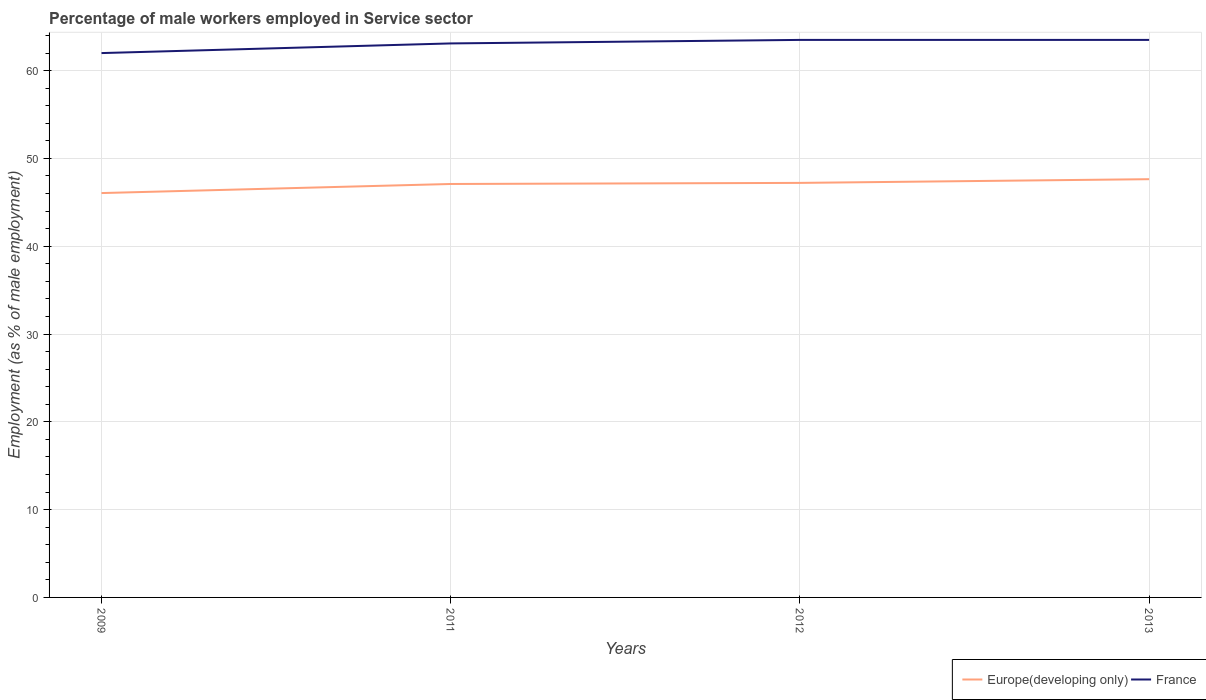Across all years, what is the maximum percentage of male workers employed in Service sector in France?
Provide a succinct answer. 62. What is the total percentage of male workers employed in Service sector in Europe(developing only) in the graph?
Provide a succinct answer. -1.03. What is the difference between the highest and the second highest percentage of male workers employed in Service sector in France?
Provide a succinct answer. 1.5. What is the difference between the highest and the lowest percentage of male workers employed in Service sector in Europe(developing only)?
Ensure brevity in your answer.  3. How many years are there in the graph?
Make the answer very short. 4. Does the graph contain any zero values?
Make the answer very short. No. Where does the legend appear in the graph?
Your answer should be very brief. Bottom right. What is the title of the graph?
Keep it short and to the point. Percentage of male workers employed in Service sector. Does "Paraguay" appear as one of the legend labels in the graph?
Your answer should be very brief. No. What is the label or title of the X-axis?
Offer a terse response. Years. What is the label or title of the Y-axis?
Provide a succinct answer. Employment (as % of male employment). What is the Employment (as % of male employment) of Europe(developing only) in 2009?
Your answer should be very brief. 46.06. What is the Employment (as % of male employment) in France in 2009?
Ensure brevity in your answer.  62. What is the Employment (as % of male employment) in Europe(developing only) in 2011?
Your answer should be compact. 47.09. What is the Employment (as % of male employment) in France in 2011?
Offer a terse response. 63.1. What is the Employment (as % of male employment) in Europe(developing only) in 2012?
Your answer should be compact. 47.21. What is the Employment (as % of male employment) in France in 2012?
Provide a succinct answer. 63.5. What is the Employment (as % of male employment) in Europe(developing only) in 2013?
Your answer should be very brief. 47.64. What is the Employment (as % of male employment) in France in 2013?
Your answer should be very brief. 63.5. Across all years, what is the maximum Employment (as % of male employment) in Europe(developing only)?
Keep it short and to the point. 47.64. Across all years, what is the maximum Employment (as % of male employment) of France?
Provide a short and direct response. 63.5. Across all years, what is the minimum Employment (as % of male employment) of Europe(developing only)?
Keep it short and to the point. 46.06. What is the total Employment (as % of male employment) of Europe(developing only) in the graph?
Your response must be concise. 188. What is the total Employment (as % of male employment) in France in the graph?
Offer a terse response. 252.1. What is the difference between the Employment (as % of male employment) in Europe(developing only) in 2009 and that in 2011?
Keep it short and to the point. -1.03. What is the difference between the Employment (as % of male employment) in Europe(developing only) in 2009 and that in 2012?
Offer a terse response. -1.16. What is the difference between the Employment (as % of male employment) in Europe(developing only) in 2009 and that in 2013?
Give a very brief answer. -1.58. What is the difference between the Employment (as % of male employment) in Europe(developing only) in 2011 and that in 2012?
Your response must be concise. -0.12. What is the difference between the Employment (as % of male employment) in Europe(developing only) in 2011 and that in 2013?
Offer a very short reply. -0.55. What is the difference between the Employment (as % of male employment) of Europe(developing only) in 2012 and that in 2013?
Provide a succinct answer. -0.42. What is the difference between the Employment (as % of male employment) in France in 2012 and that in 2013?
Offer a terse response. 0. What is the difference between the Employment (as % of male employment) of Europe(developing only) in 2009 and the Employment (as % of male employment) of France in 2011?
Give a very brief answer. -17.04. What is the difference between the Employment (as % of male employment) in Europe(developing only) in 2009 and the Employment (as % of male employment) in France in 2012?
Provide a succinct answer. -17.44. What is the difference between the Employment (as % of male employment) in Europe(developing only) in 2009 and the Employment (as % of male employment) in France in 2013?
Provide a short and direct response. -17.44. What is the difference between the Employment (as % of male employment) of Europe(developing only) in 2011 and the Employment (as % of male employment) of France in 2012?
Offer a very short reply. -16.41. What is the difference between the Employment (as % of male employment) in Europe(developing only) in 2011 and the Employment (as % of male employment) in France in 2013?
Make the answer very short. -16.41. What is the difference between the Employment (as % of male employment) in Europe(developing only) in 2012 and the Employment (as % of male employment) in France in 2013?
Your answer should be very brief. -16.29. What is the average Employment (as % of male employment) of Europe(developing only) per year?
Offer a terse response. 47. What is the average Employment (as % of male employment) in France per year?
Provide a succinct answer. 63.02. In the year 2009, what is the difference between the Employment (as % of male employment) of Europe(developing only) and Employment (as % of male employment) of France?
Your answer should be compact. -15.94. In the year 2011, what is the difference between the Employment (as % of male employment) of Europe(developing only) and Employment (as % of male employment) of France?
Provide a short and direct response. -16.01. In the year 2012, what is the difference between the Employment (as % of male employment) in Europe(developing only) and Employment (as % of male employment) in France?
Your response must be concise. -16.29. In the year 2013, what is the difference between the Employment (as % of male employment) in Europe(developing only) and Employment (as % of male employment) in France?
Keep it short and to the point. -15.86. What is the ratio of the Employment (as % of male employment) in France in 2009 to that in 2011?
Your answer should be compact. 0.98. What is the ratio of the Employment (as % of male employment) of Europe(developing only) in 2009 to that in 2012?
Ensure brevity in your answer.  0.98. What is the ratio of the Employment (as % of male employment) of France in 2009 to that in 2012?
Your answer should be compact. 0.98. What is the ratio of the Employment (as % of male employment) of Europe(developing only) in 2009 to that in 2013?
Keep it short and to the point. 0.97. What is the ratio of the Employment (as % of male employment) of France in 2009 to that in 2013?
Your response must be concise. 0.98. What is the ratio of the Employment (as % of male employment) in France in 2011 to that in 2012?
Make the answer very short. 0.99. What is the ratio of the Employment (as % of male employment) of France in 2011 to that in 2013?
Keep it short and to the point. 0.99. What is the ratio of the Employment (as % of male employment) in Europe(developing only) in 2012 to that in 2013?
Your response must be concise. 0.99. What is the difference between the highest and the second highest Employment (as % of male employment) of Europe(developing only)?
Give a very brief answer. 0.42. What is the difference between the highest and the lowest Employment (as % of male employment) in Europe(developing only)?
Provide a succinct answer. 1.58. 